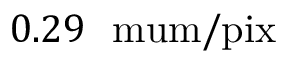Convert formula to latex. <formula><loc_0><loc_0><loc_500><loc_500>0 . 2 9 { \ m u m / p i x }</formula> 